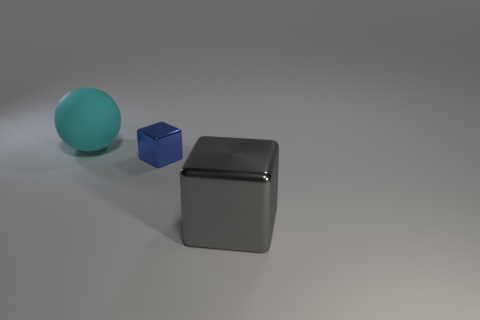Add 3 small shiny cubes. How many objects exist? 6 Subtract all blocks. How many objects are left? 1 Add 1 small green cylinders. How many small green cylinders exist? 1 Subtract 0 yellow balls. How many objects are left? 3 Subtract all big green cylinders. Subtract all large gray metal blocks. How many objects are left? 2 Add 1 big balls. How many big balls are left? 2 